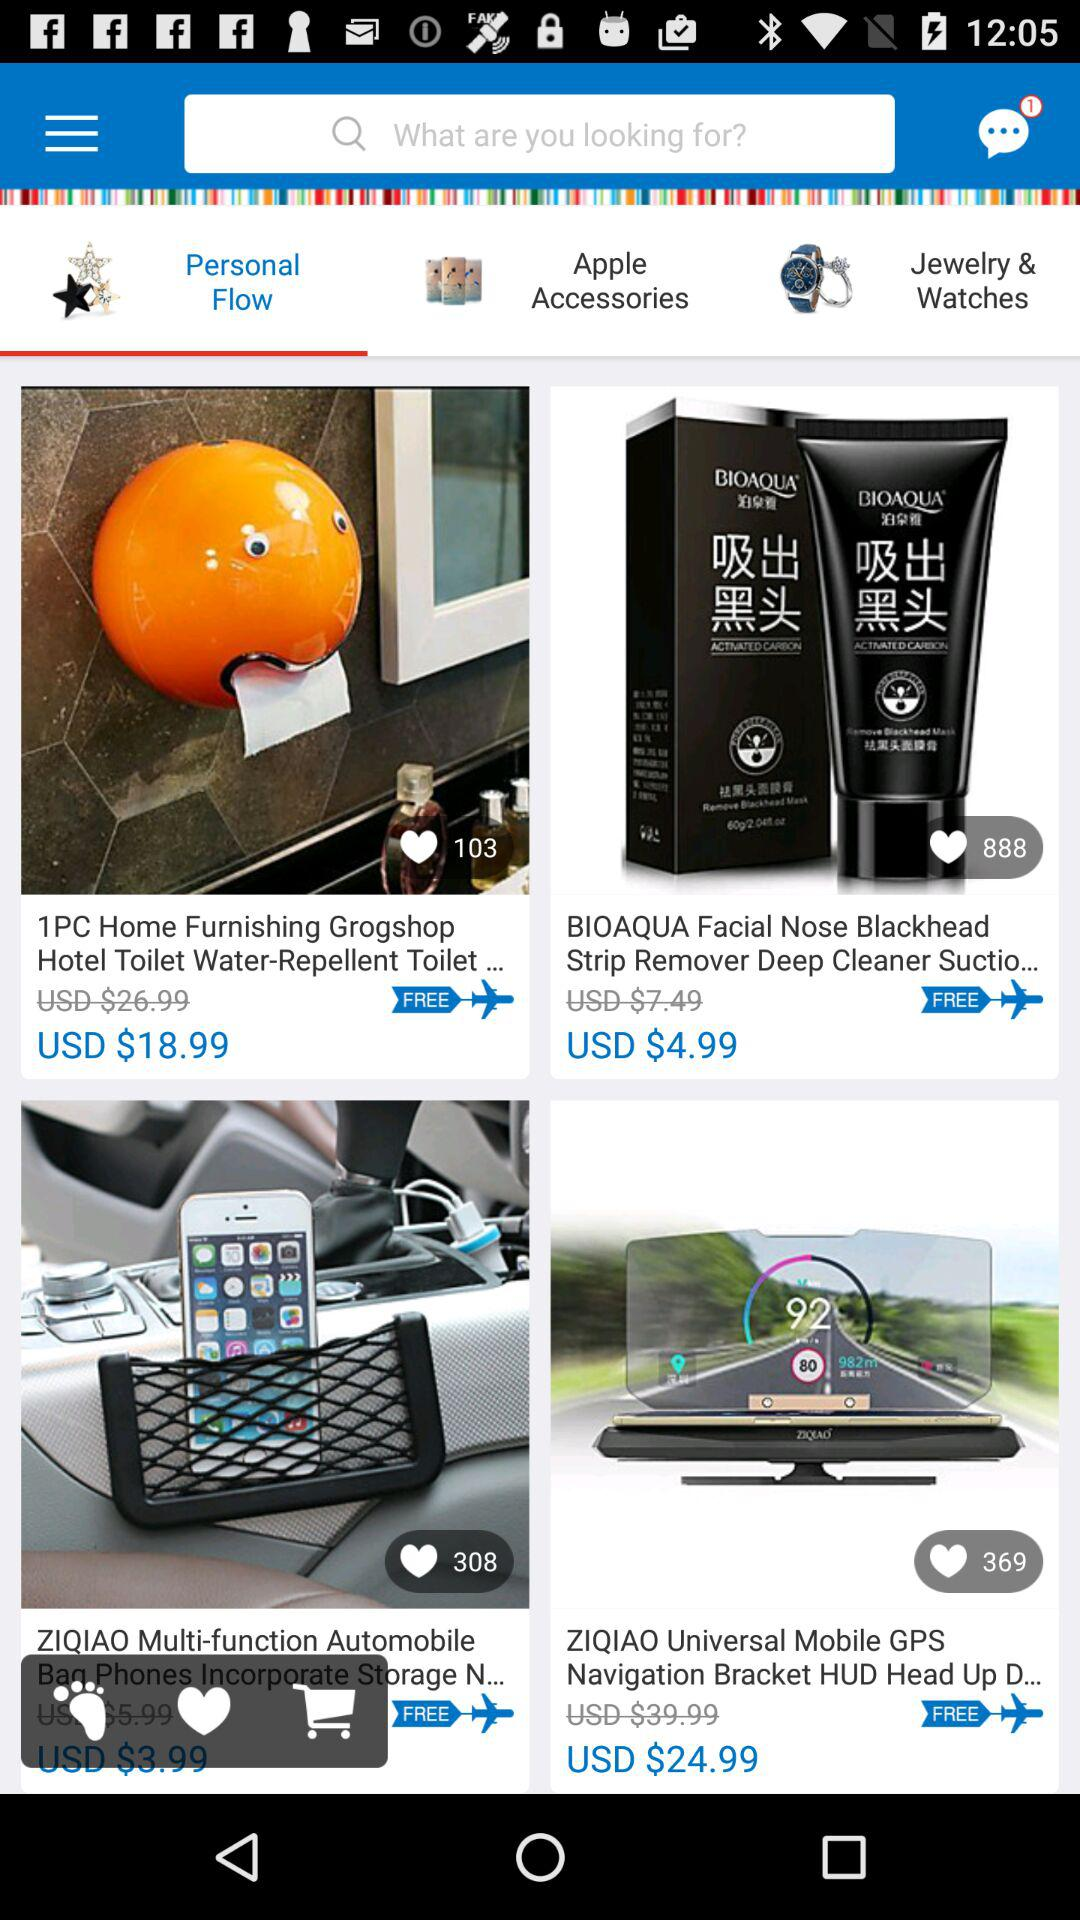What is typed into the search bar?
When the provided information is insufficient, respond with <no answer>. <no answer> 